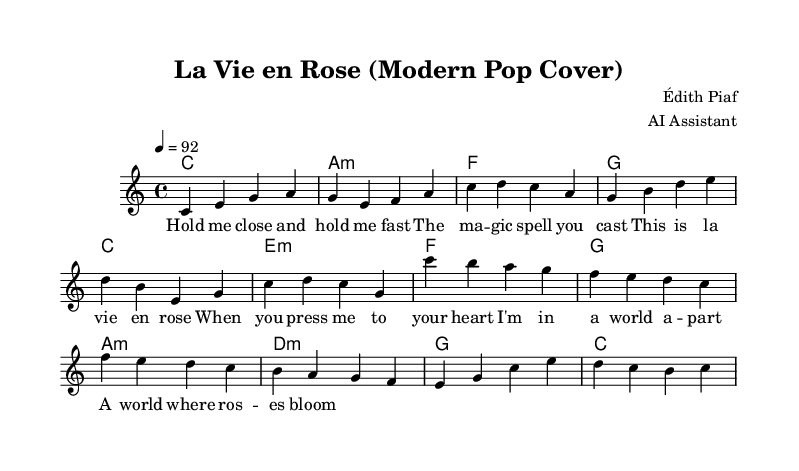What is the key signature of this music? The key signature is C major, which has no sharps or flats.
Answer: C major What is the time signature of this piece? The time signature is indicated at the beginning of the score, which shows that there are four beats per measure.
Answer: 4/4 What is the tempo marking for this piece? The tempo marking is provided in the score, set to a quarter note equals ninety-two beats per minute.
Answer: 92 How many verses are present in the lyrics? By looking at the structure of the lyrics provided, there is one verse and one chorus. The verse is followed by the chorus, signifying a foundational structure.
Answer: 1 What chord follows the A minor chord in the verse progression? Analyzing the chord progression in the verse section, after A minor, the next chord listed is F.
Answer: F What instrument primarily carries the melody in this arrangement? The melody is indicated in the score under the voice part, which shows that this arrangement is focused on vocal performance.
Answer: Voice What is the first lyric line of the chorus? The first line of the chorus is written clearly in the lyric part, which starts with "When you press me to your heart".
Answer: When you press me to your heart 